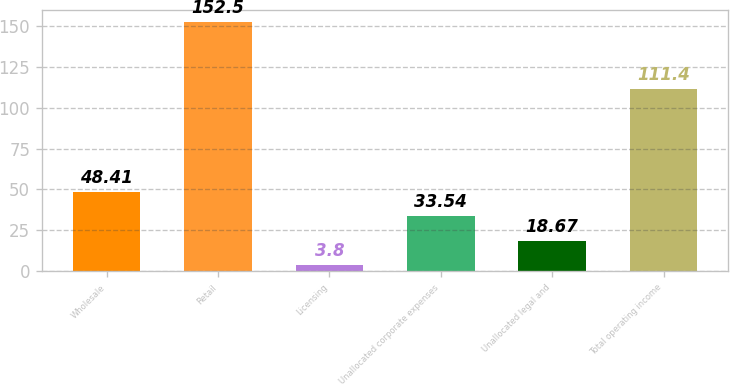Convert chart. <chart><loc_0><loc_0><loc_500><loc_500><bar_chart><fcel>Wholesale<fcel>Retail<fcel>Licensing<fcel>Unallocated corporate expenses<fcel>Unallocated legal and<fcel>Total operating income<nl><fcel>48.41<fcel>152.5<fcel>3.8<fcel>33.54<fcel>18.67<fcel>111.4<nl></chart> 